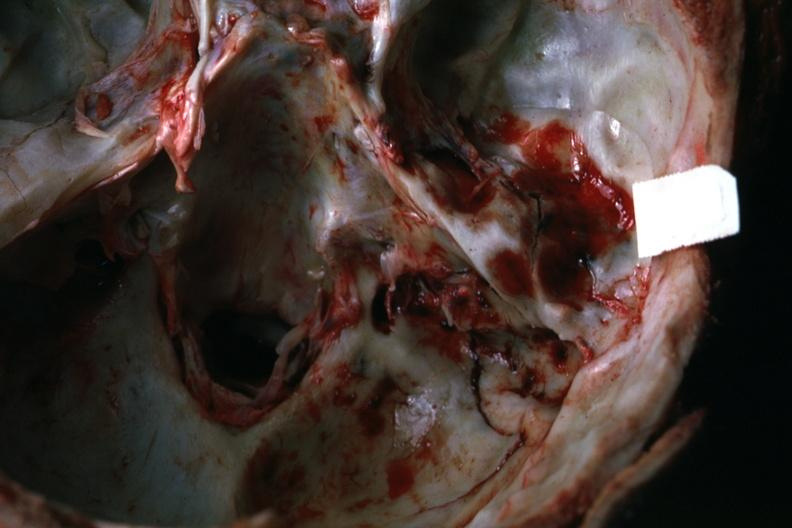s nodule present?
Answer the question using a single word or phrase. No 